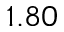Convert formula to latex. <formula><loc_0><loc_0><loc_500><loc_500>1 . 8 0</formula> 